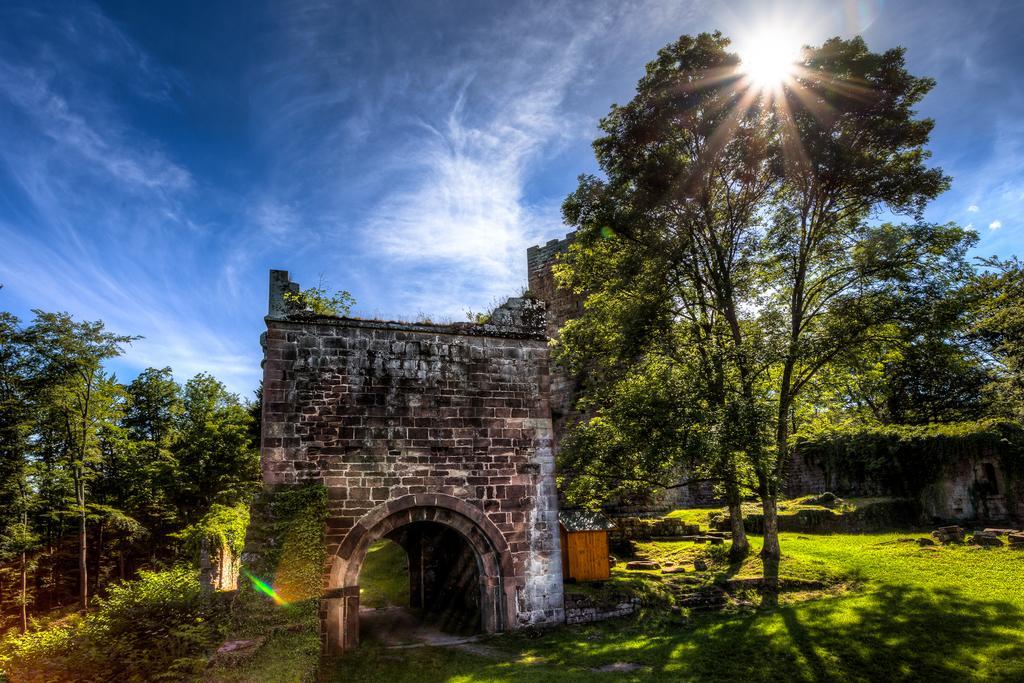Please provide a concise description of this image. At the bottom we can see grass and plants on the ground. In the middle there is an arch and beside it there is a small room. In the background we can see trees,an ancient building,wall,sun and clouds in the sky. 